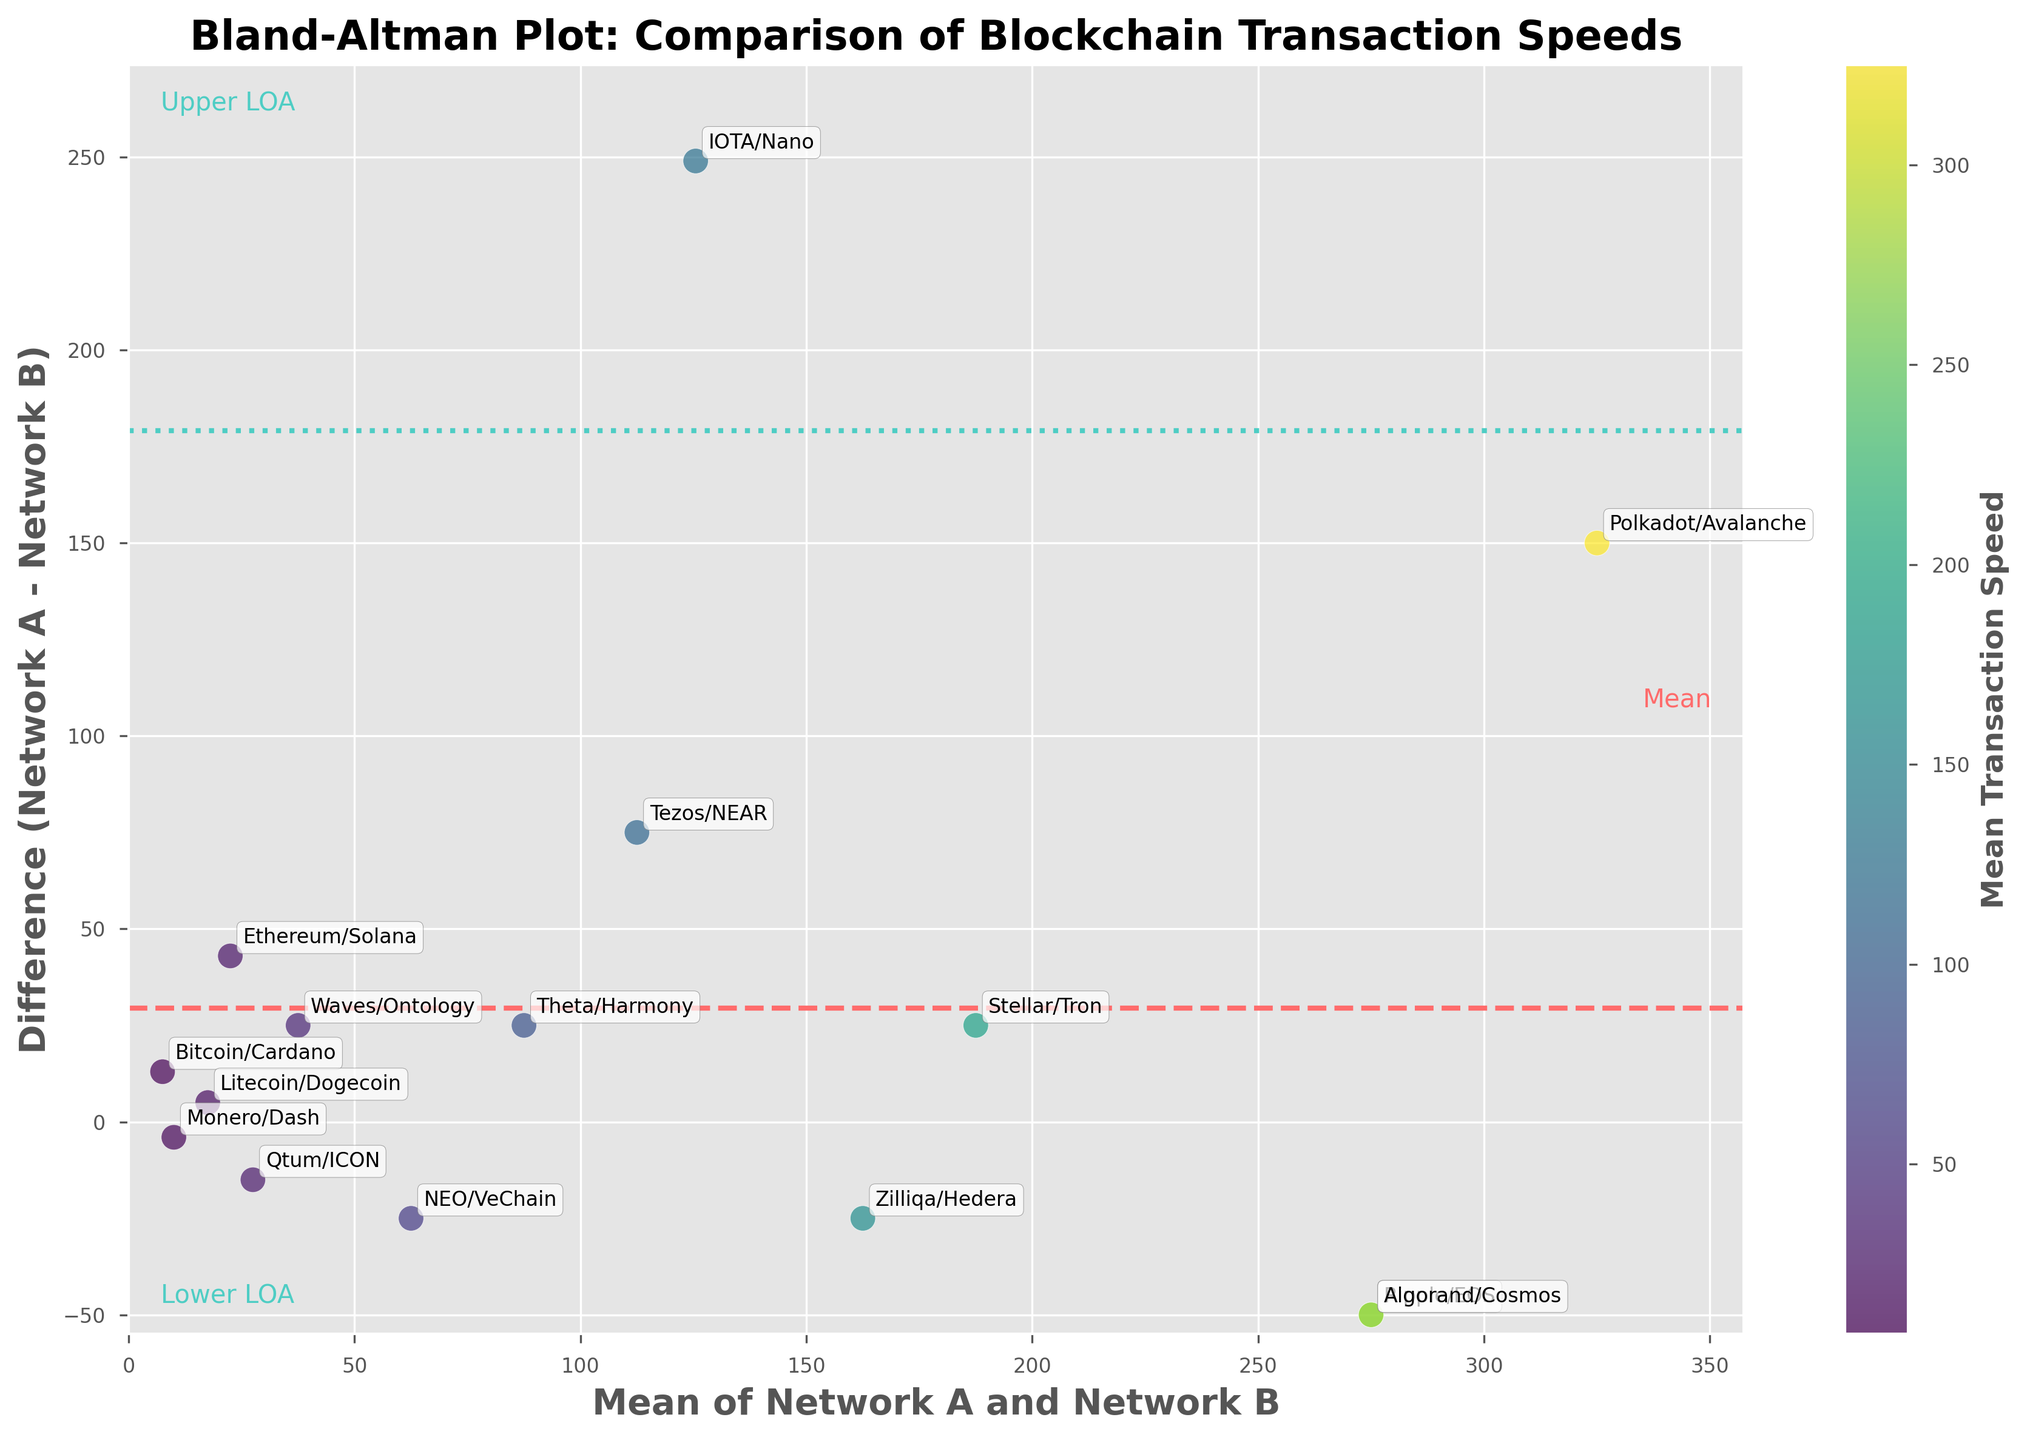what is the title of the plot? The title of the plot is typically displayed at the top center of the figure. In this case, the title explicitly states what the figure represents.
Answer: Bland-Altman Plot: Comparison of Blockchain Transaction Speeds Which pair of networks has the highest average transaction speed? To find the pair with the highest average transaction speed, refer to the x-axis, which represents the mean values of each pair. Identify the data point farthest to the right.
Answer: Polkadot/Avalanche What color represents the mean transaction speeds of the networks? The colors representing mean transaction speeds are indicated by the color bar. The plot uses a color gradient to encode the mean transaction speeds.
Answer: Viridis (color gradient) How many data points represent negative differences in transaction speed? Negative differences can be identified by looking below the zero line on the y-axis. Count the number of points below the x-axis.
Answer: 5 Which pair has the largest positive difference in transaction speed? The largest positive difference is the highest point above the zero line on the y-axis. In this case, identify the topmost data point.
Answer: IOTA/Nano What is the mean line's color? The mean line is the horizontal dashed line going through the y-axis.
Answer: Red (dashed line) What bounds the 95% limits of agreement (LOA)? The LOA lines are the horizontal dashed lines above and below the mean line. Their colors and positions are identified by the vertical distances from the mean line, marked by points on the y-axis.
Answer: Green (dotted lines) Identify the outlier with the greatest difference from the mean. The outliers can be found as points that deviate significantly from the mean difference line. Identify the point that is farthest from the mean line.
Answer: IOTA/Nano Are there more positive or negative differences in network transaction speeds? Compare the number of points above and below the zero-difference line on the y-axis.
Answer: More positive What network pairs are within the limits of agreement? Points within the 95% limits of agreement lie between the upper and lower LOA lines. Identify the pairs falling within these limits.
Answer: Ethereum/Solana, Monero/Dash, Litecoin/Dogecoin, Qtum/ICON, Theta/Harmony 